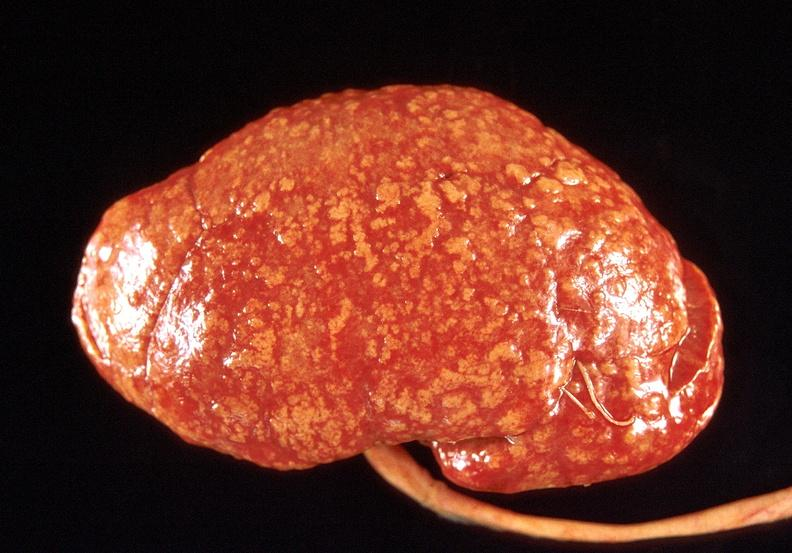where is this?
Answer the question using a single word or phrase. Urinary 